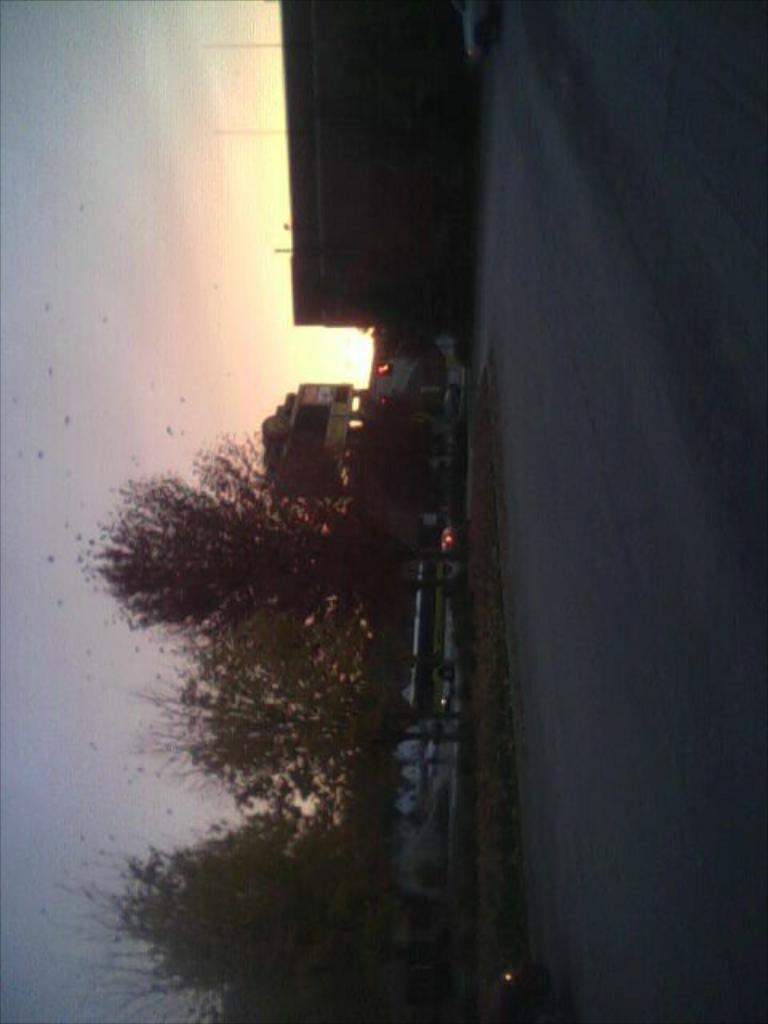What type of natural elements can be seen in the image? There are trees in the image. What man-made objects are present in the image? There are vehicles in the image. Where are the vehicles located in the image? The vehicles are in the middle of the image. What structures can be seen at the top of the image? There are buildings at the top of the image. What part of the natural environment is visible in the image? The sky is visible in the background of the image. What is the primary pathway in the image? There is a road on the left side of the image. How many eggs are being used to build the muscle in the image? There are no eggs or muscles present in the image; it features trees, vehicles, buildings, a road, and the sky. 